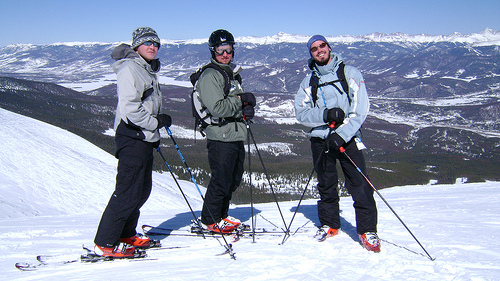Please provide a short description for this region: [0.27, 0.47, 0.46, 0.74]. This region prominently displays a pair of ski poles with sleek blue and black designs, complementing the snowy backdrop. 